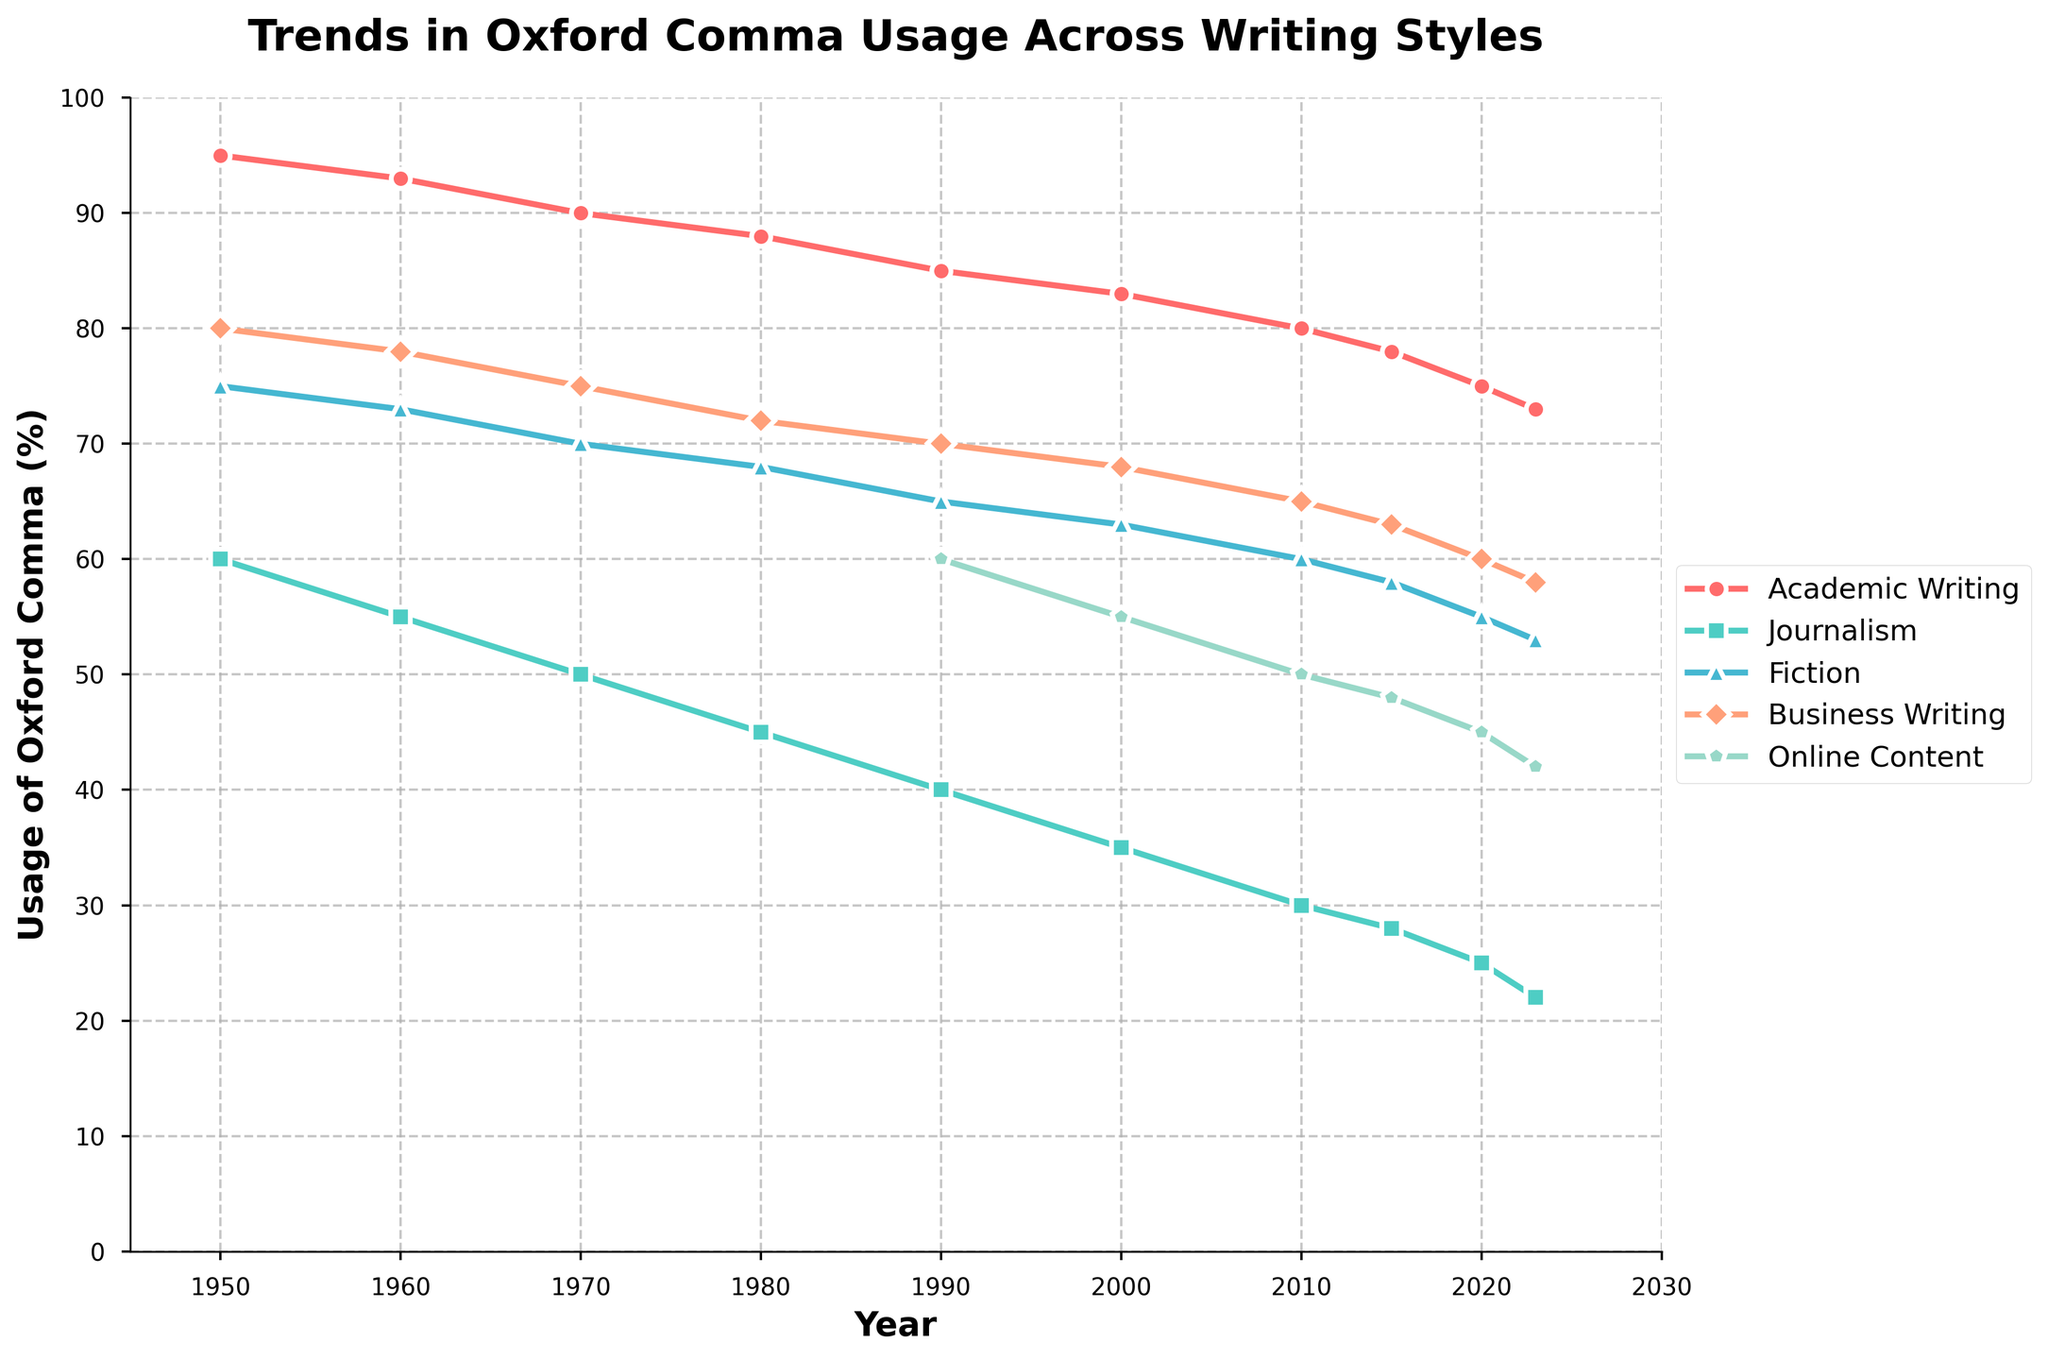Which writing style consistently shows the highest usage of the Oxford comma? By looking at the line chart, the trend line with the highest values throughout the entire range is the line representing Academic Writing.
Answer: Academic Writing Between 1980 and 2023, which writing style saw the largest drop in the usage of the Oxford comma? To determine this, examine the difference between the values in 1980 and 2023 for each writing style. Journalism shows the largest drop from 45% in 1980 to 22% in 2023, a drop of 23 percentage points.
Answer: Journalism What is the general trend of the usage of the Oxford comma in Online Content since 1990? The line representing Online Content starts at 60% usage in 1990 and steadily decreases until it reaches 42% in 2023.
Answer: Decreasing In 2023, which writing style has the closest usage percentage to Fiction? By comparing the values of different writing styles in 2023, Fiction has a usage percentage of 53%. Business Writing is closest with 58%.
Answer: Business Writing Which decade saw the steepest decline in the usage of the Oxford comma across all writing styles on average? To determine this, calculate the average decline for each decade. The steepest declines appear between 1960 and 1970 for all styles, notably Academic Writing (-3), Journalism (-5), Fiction (-3), and Business Writing (-3). The exact decade would need the mean calculation, but visually, the 1960-1970 period is sharpest.
Answer: 1960-1970 How does the usage of the Oxford comma in Fiction compare to Business Writing in 1980? In 1980, Fiction's usage is at 68%, whereas Business Writing's usage is at 72%. Fiction has a slightly lower usage than Business Writing in that year.
Answer: Fiction is lower Has any writing style shown an increase in the usage of the Oxford comma over the years? By examining all the lines on the chart, all writing styles show a decreasing trend over the years.
Answer: No In which year did Journalism usage drop below 50%? From the chart, Journalism dropped from 50% in 1970 to 45% in 1980. The drop below 50% occurs after 1970.
Answer: After 1970 Which writing style shows the least amount of variability in the usage of the Oxford comma from 1950 to 2023? Observing the trends, Academic Writing shows the least variability, maintaining a relatively high and stable percentage throughout the years.
Answer: Academic Writing 